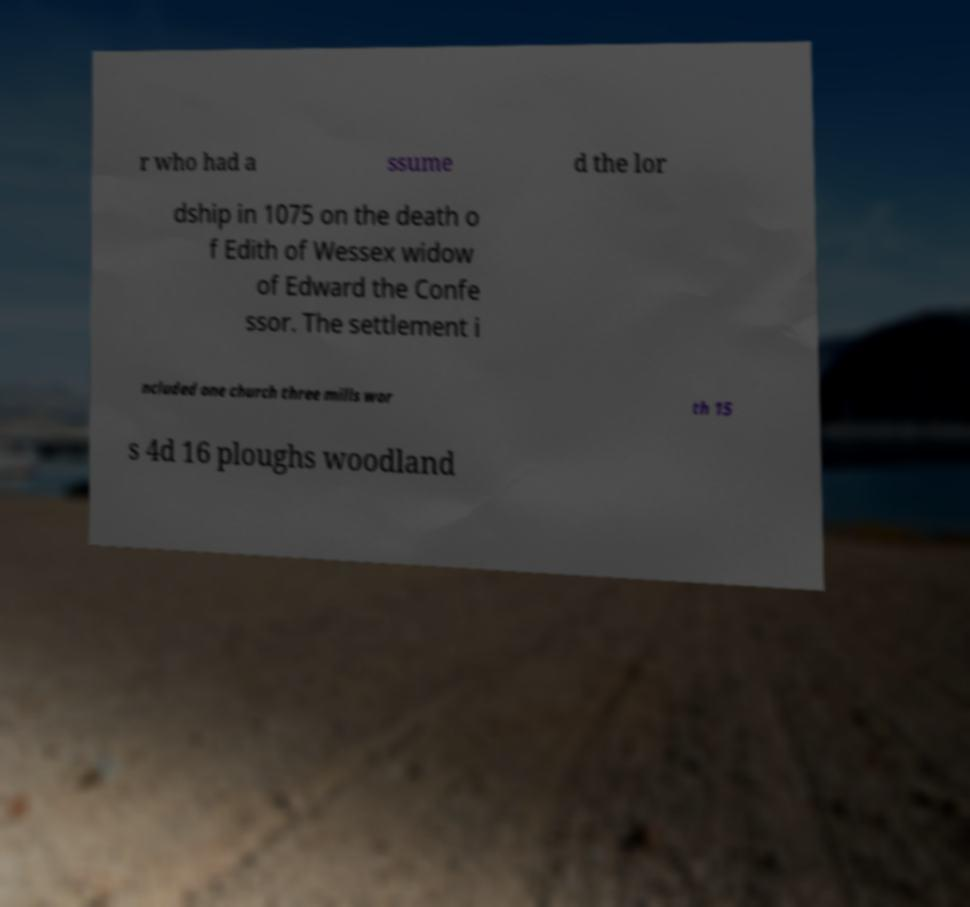I need the written content from this picture converted into text. Can you do that? r who had a ssume d the lor dship in 1075 on the death o f Edith of Wessex widow of Edward the Confe ssor. The settlement i ncluded one church three mills wor th 15 s 4d 16 ploughs woodland 